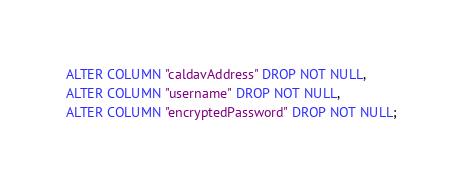Convert code to text. <code><loc_0><loc_0><loc_500><loc_500><_SQL_>ALTER COLUMN "caldavAddress" DROP NOT NULL,
ALTER COLUMN "username" DROP NOT NULL,
ALTER COLUMN "encryptedPassword" DROP NOT NULL;
</code> 